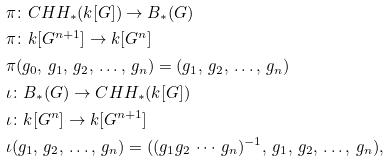Convert formula to latex. <formula><loc_0><loc_0><loc_500><loc_500>& \pi \colon C H H _ { * } ( k [ G ] ) \to B _ { * } ( G ) \\ & \pi \colon k [ G ^ { n + 1 } ] \to k [ G ^ { n } ] \\ & \pi ( g _ { 0 } , \, g _ { 1 } , \, g _ { 2 } , \, \dots , \, g _ { n } ) = ( g _ { 1 } , \, g _ { 2 } , \, \dots , \, g _ { n } ) & \\ & \iota \colon B _ { * } ( G ) \to C H H _ { * } ( k [ G ] ) \\ & \iota \colon k [ G ^ { n } ] \to k [ G ^ { n + 1 } ] \\ & \iota ( g _ { 1 } , \, g _ { 2 } , \, \dots , \, g _ { n } ) = ( ( g _ { 1 } g _ { 2 } \, \cdots \, g _ { n } ) ^ { - 1 } , \, g _ { 1 } , \, g _ { 2 } , \, \dots , \, g _ { n } ) ,</formula> 